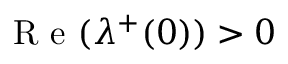Convert formula to latex. <formula><loc_0><loc_0><loc_500><loc_500>R e ( \lambda ^ { + } ( 0 ) ) > 0</formula> 